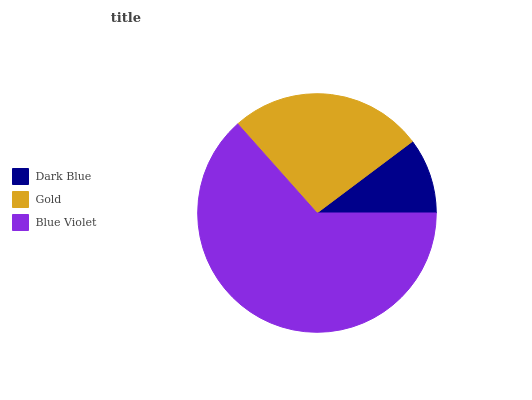Is Dark Blue the minimum?
Answer yes or no. Yes. Is Blue Violet the maximum?
Answer yes or no. Yes. Is Gold the minimum?
Answer yes or no. No. Is Gold the maximum?
Answer yes or no. No. Is Gold greater than Dark Blue?
Answer yes or no. Yes. Is Dark Blue less than Gold?
Answer yes or no. Yes. Is Dark Blue greater than Gold?
Answer yes or no. No. Is Gold less than Dark Blue?
Answer yes or no. No. Is Gold the high median?
Answer yes or no. Yes. Is Gold the low median?
Answer yes or no. Yes. Is Blue Violet the high median?
Answer yes or no. No. Is Blue Violet the low median?
Answer yes or no. No. 